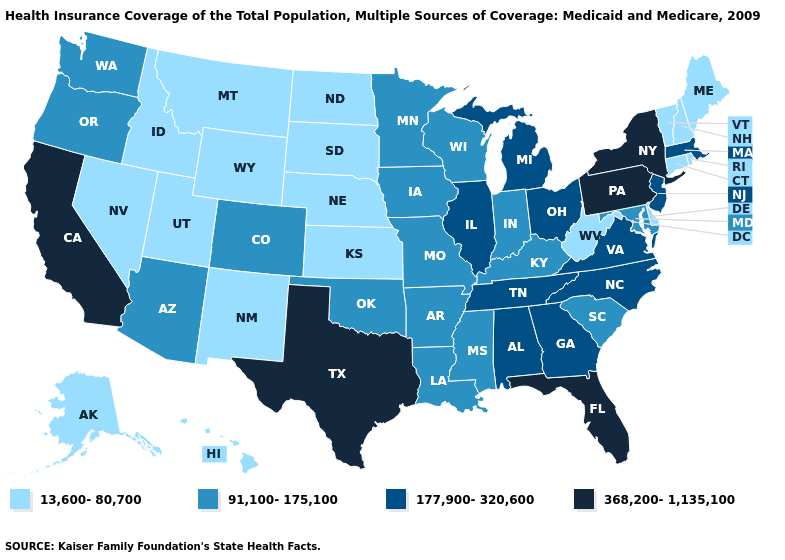Does Idaho have a higher value than Kansas?
Answer briefly. No. Name the states that have a value in the range 13,600-80,700?
Concise answer only. Alaska, Connecticut, Delaware, Hawaii, Idaho, Kansas, Maine, Montana, Nebraska, Nevada, New Hampshire, New Mexico, North Dakota, Rhode Island, South Dakota, Utah, Vermont, West Virginia, Wyoming. Does Rhode Island have a higher value than Connecticut?
Write a very short answer. No. Name the states that have a value in the range 368,200-1,135,100?
Short answer required. California, Florida, New York, Pennsylvania, Texas. Which states have the lowest value in the South?
Concise answer only. Delaware, West Virginia. What is the highest value in the USA?
Be succinct. 368,200-1,135,100. Which states have the lowest value in the West?
Answer briefly. Alaska, Hawaii, Idaho, Montana, Nevada, New Mexico, Utah, Wyoming. What is the lowest value in the USA?
Answer briefly. 13,600-80,700. What is the value of Kansas?
Write a very short answer. 13,600-80,700. Name the states that have a value in the range 13,600-80,700?
Write a very short answer. Alaska, Connecticut, Delaware, Hawaii, Idaho, Kansas, Maine, Montana, Nebraska, Nevada, New Hampshire, New Mexico, North Dakota, Rhode Island, South Dakota, Utah, Vermont, West Virginia, Wyoming. Does the first symbol in the legend represent the smallest category?
Short answer required. Yes. Does the map have missing data?
Be succinct. No. Among the states that border Tennessee , which have the lowest value?
Answer briefly. Arkansas, Kentucky, Mississippi, Missouri. Does Delaware have the same value as Massachusetts?
Short answer required. No. Among the states that border Alabama , which have the highest value?
Concise answer only. Florida. 